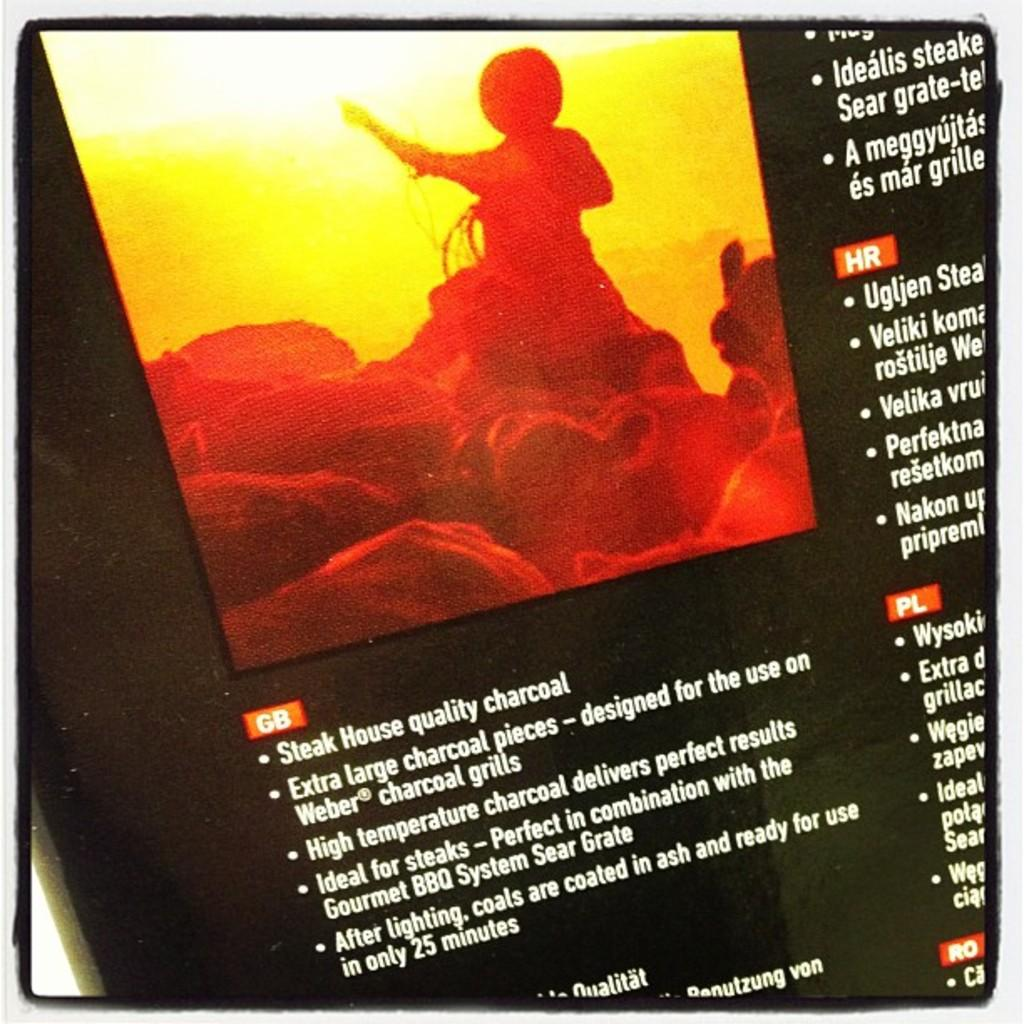<image>
Offer a succinct explanation of the picture presented. A advert for charcoal saying it is Steak House quality. 